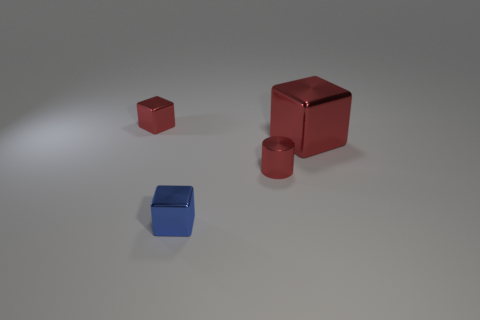Subtract all blue cubes. How many cubes are left? 2 Subtract all blue cubes. How many cubes are left? 2 Subtract all cylinders. How many objects are left? 3 Subtract all blue blocks. How many blue cylinders are left? 0 Subtract all purple cylinders. Subtract all large things. How many objects are left? 3 Add 2 small red metallic cylinders. How many small red metallic cylinders are left? 3 Add 2 tiny purple rubber objects. How many tiny purple rubber objects exist? 2 Add 1 small metallic cylinders. How many objects exist? 5 Subtract 0 gray blocks. How many objects are left? 4 Subtract all gray blocks. Subtract all blue spheres. How many blocks are left? 3 